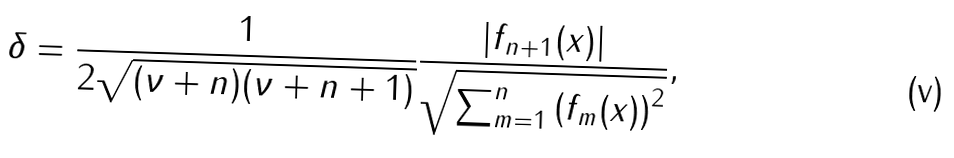Convert formula to latex. <formula><loc_0><loc_0><loc_500><loc_500>\delta = \frac { 1 } { 2 \sqrt { ( \nu + n ) ( \nu + n + 1 ) } } \frac { \left | f _ { n + 1 } ( x ) \right | } { \sqrt { \sum _ { m = 1 } ^ { n } \left ( f _ { m } ( x ) \right ) ^ { 2 } } } ,</formula> 